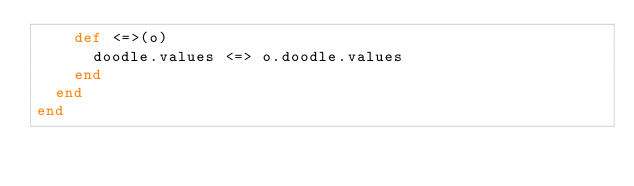<code> <loc_0><loc_0><loc_500><loc_500><_Ruby_>    def <=>(o)
      doodle.values <=> o.doodle.values
    end
  end
end
</code> 